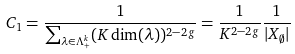<formula> <loc_0><loc_0><loc_500><loc_500>C _ { 1 } & = \frac { 1 } { \sum \nolimits _ { \lambda \in \Lambda ^ { k } _ { + } } ( K \dim ( \lambda ) ) ^ { 2 - 2 g } } = \frac { 1 } { K ^ { 2 - 2 g } } \frac { 1 } { | X _ { \emptyset } | }</formula> 